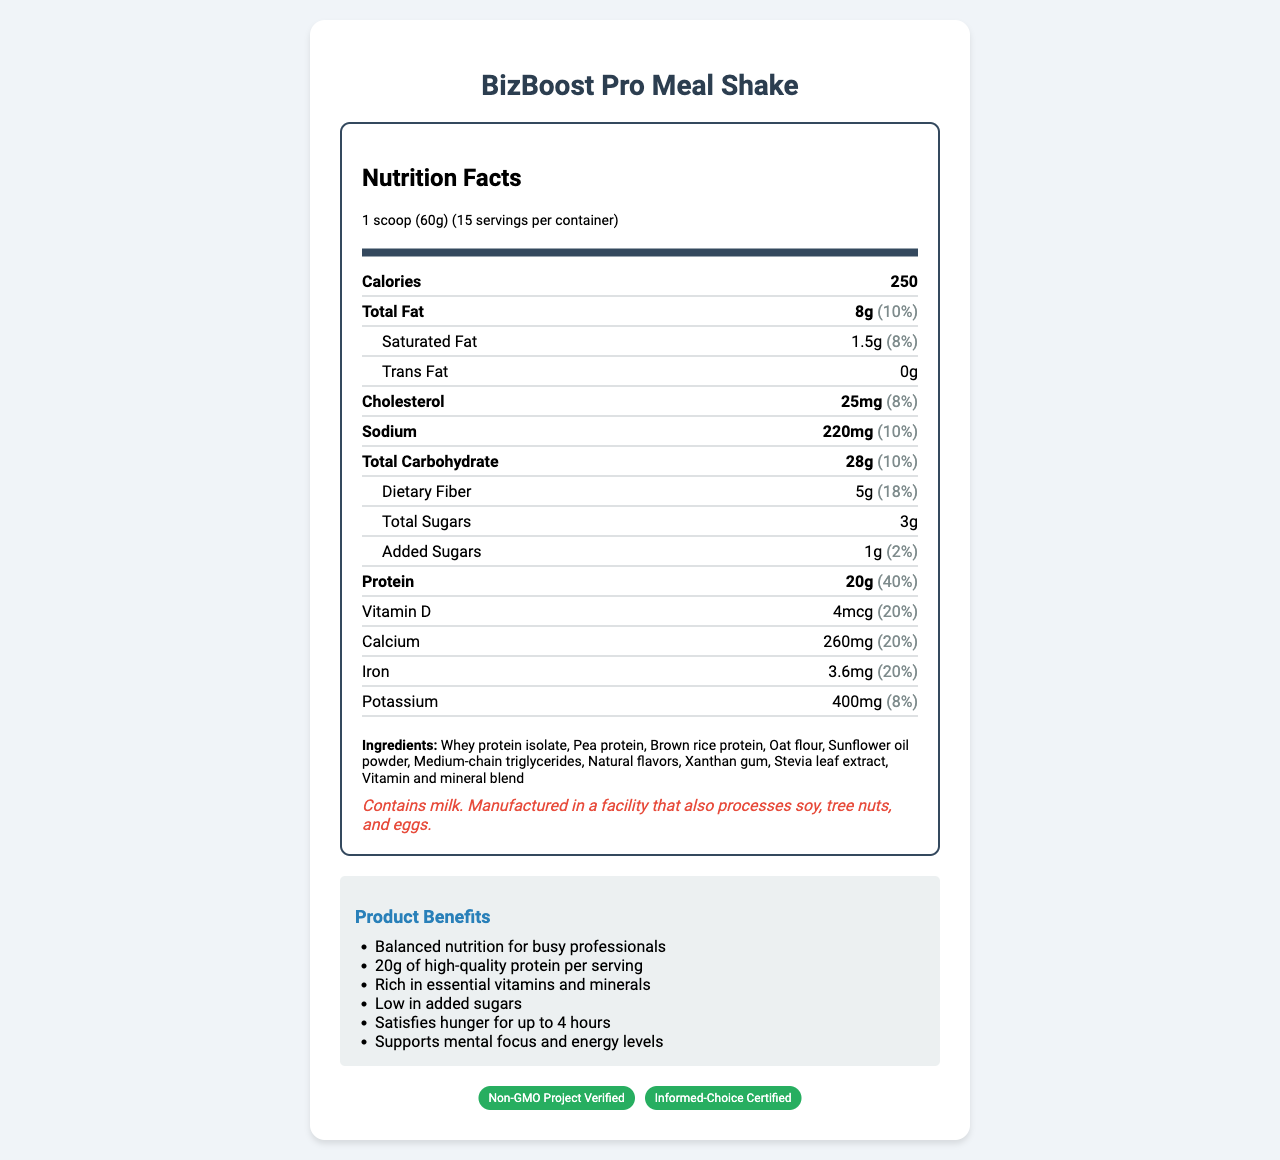what is the serving size for BizBoost Pro Meal Shake? The serving size is listed at the top of the Nutrition Facts section as "1 scoop (60g)".
Answer: 1 scoop (60g) how many servings are there in one container? The servings per container are mentioned next to the serving size as "15".
Answer: 15 how many calories are in one serving of the shake? The calories are clearly listed as 250 in the bold "Calories" row within the Nutrition Facts.
Answer: 250 what is the amount of total fat in one serving? This amount is listed under "Total Fat" in the Nutrition Facts section as 8g.
Answer: 8g what type of proteins are used in this meal shake? These ingredients are listed in the "Ingredients" section.
Answer: Whey protein isolate, Pea protein, Brown rice protein how much dietary fiber does one serving contain? This information is found under "Dietary Fiber" in the Nutrition Facts section.
Answer: 5g what percentage of the daily value of Vitamin D is provided in one serving? The daily value percentage for Vitamin D is listed alongside its amount.
Answer: 20% how much added sugars are there in one serving of the shake? The added sugars amount is listed as 1g in the Nutrition Facts.
Answer: 1g how long does the product claim to satisfy hunger? This information is listed as a marketing claim: "Satisfies hunger for up to 4 hours".
Answer: Up to 4 hours who is the target audience for this product? This information is clearly stated under the "target_audience" header.
Answer: Busy professionals, entrepreneurs, and business executives how should one prepare the shake? Preparation instructions are detailed under the "recommended_use" section.
Answer: Mix one scoop (60g) with 10-12 oz of cold water or your preferred beverage. Shake well and enjoy as a meal replacement or nutritious snack. True or False: The BizBoost Pro Meal Shake is free from any allergens. The allergen information clearly states that it contains milk and is manufactured in a facility that processes soy, tree nuts, and eggs.
Answer: False what certifications does the product have? This information is listed at the bottom of the document under "certifications".
Answer: Non-GMO Project Verified, Informed-Choice Certified which of the following is an ingredient in the BizBoost Pro Meal Shake? A. Coconut Oil B. Brown rice protein C. Soy Protein D. Aspartame The ingredient list includes Brown rice protein, but none of the other options.
Answer: B how much protein is in one serving? A. 10g B. 15g C. 20g D. 25g The protein amount is listed as 20g in the Nutrition Facts section.
Answer: C what is the shelf life of the product? The shelf life is listed under "shelf_life" as 18 months.
Answer: 18 months which minerals are present in the shake and what are their daily value percentages? These minerals and their daily values are all listed in the Nutrition Facts section.
Answer: Phosphorus 18%, Iodine 25%, Magnesium 19%, Zinc 25%, Selenium 25%, Copper 25%, Manganese 25%, Chromium 25%, Molybdenum 25% how does this meal shake support mental focus? A. High protein content B. Low added sugars C. Balanced essential vitamins and minerals D. Rich in dietary fiber One of the marketing claims is "Supports mental focus and energy levels," and this is achieved through a "Rich in essential vitamins and minerals."
Answer: C can you describe the main idea of the document? The document covers the necessary information for consumers, from nutritional content to usage and certifications.
Answer: The document provides detailed nutrition facts, ingredients, allergen information, and marketing claims for the BizBoost Pro Meal Shake, a meal replacement shake for busy professionals. It highlights its balanced nutrition, high protein content, essential vitamins and minerals, and low added sugars. The document also includes preparation instructions, target audience, packaging and certifications. who is the manufacturer of the BizBoost Pro Meal Shake? The document does not provide any details about the manufacturer.
Answer: Not enough information 